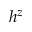<formula> <loc_0><loc_0><loc_500><loc_500>h ^ { z }</formula> 